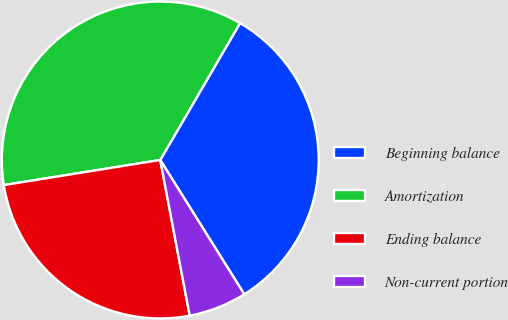<chart> <loc_0><loc_0><loc_500><loc_500><pie_chart><fcel>Beginning balance<fcel>Amortization<fcel>Ending balance<fcel>Non-current portion<nl><fcel>32.7%<fcel>35.93%<fcel>25.44%<fcel>5.92%<nl></chart> 